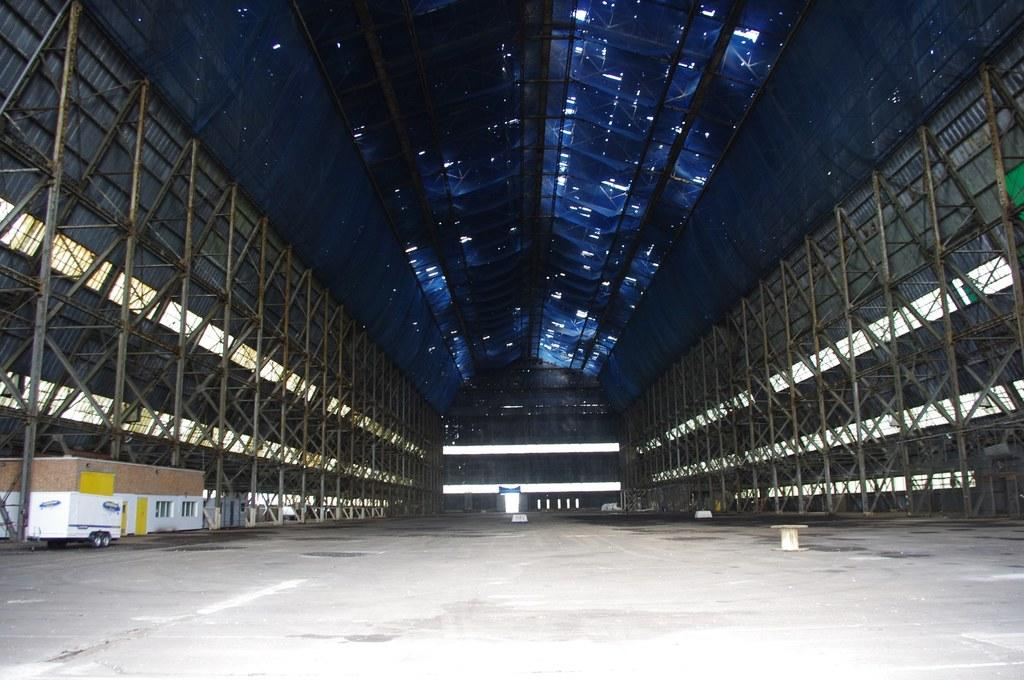What is the main subject of the image? There is a vehicle in the image. What can be seen on the floor in the image? There is an object on the floor in the image. What type of structure is present in the image? There is a house in the image. What feature of the house is mentioned in the facts? The house has windows. What type of structural element is visible in the image? There are rods visible in the image. What is the uppermost part of the room in the image? There is a ceiling in the image. What is the father doing in the image? There is no father present in the image. Is there a fight happening in the image? There is no fight depicted in the image. How many hands are visible in the image? There is no mention of hands in the provided facts, so we cannot determine how many are visible in the image. 